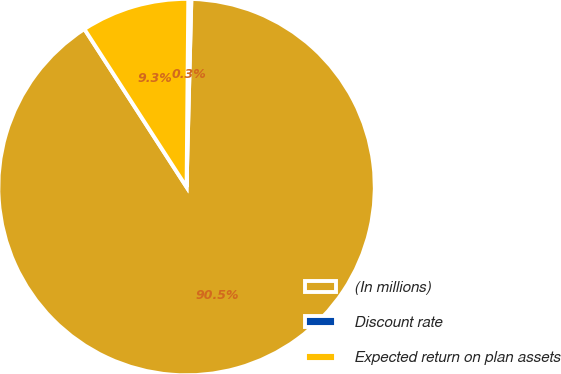Convert chart to OTSL. <chart><loc_0><loc_0><loc_500><loc_500><pie_chart><fcel>(In millions)<fcel>Discount rate<fcel>Expected return on plan assets<nl><fcel>90.45%<fcel>0.26%<fcel>9.28%<nl></chart> 